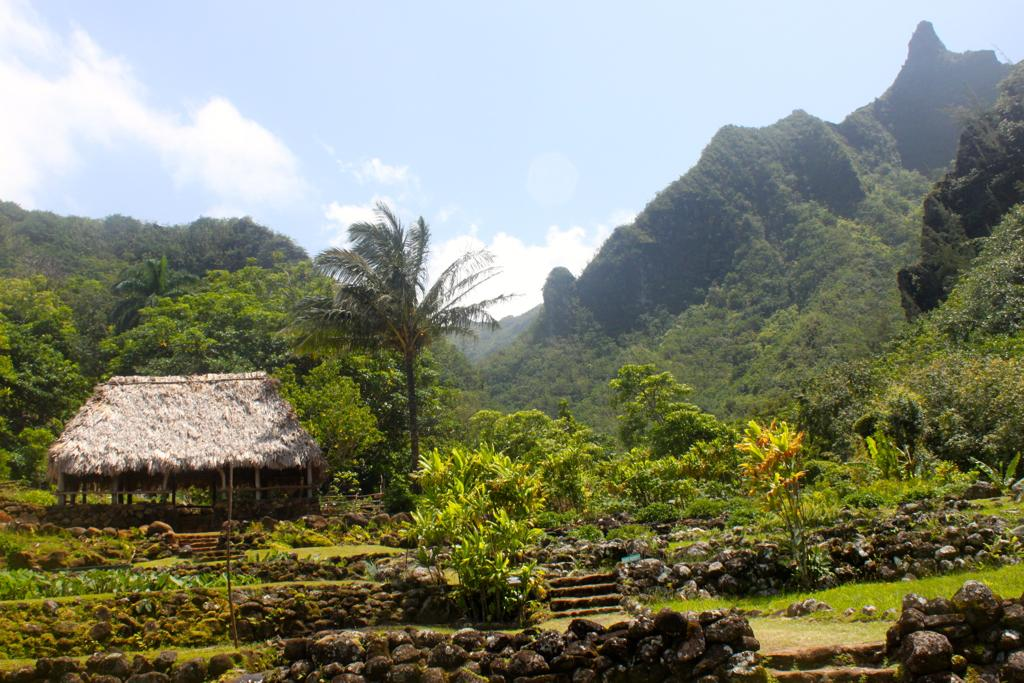Where was the image taken? The image was clicked outside. What can be seen in the background of the image? There are many trees and plants in the image. What structure is located on the left side of the image? There is a hut on the left side of the image. What is visible at the top of the image? The sky is visible at the top of the image. How many servants are present in the image? There are no servants present in the image. What disease can be seen affecting the plants in the image? There is no disease affecting the plants in the image; they appear healthy. Can you hear someone sneezing in the image? There is no sound in the image, so it is not possible to hear someone sneezing. 